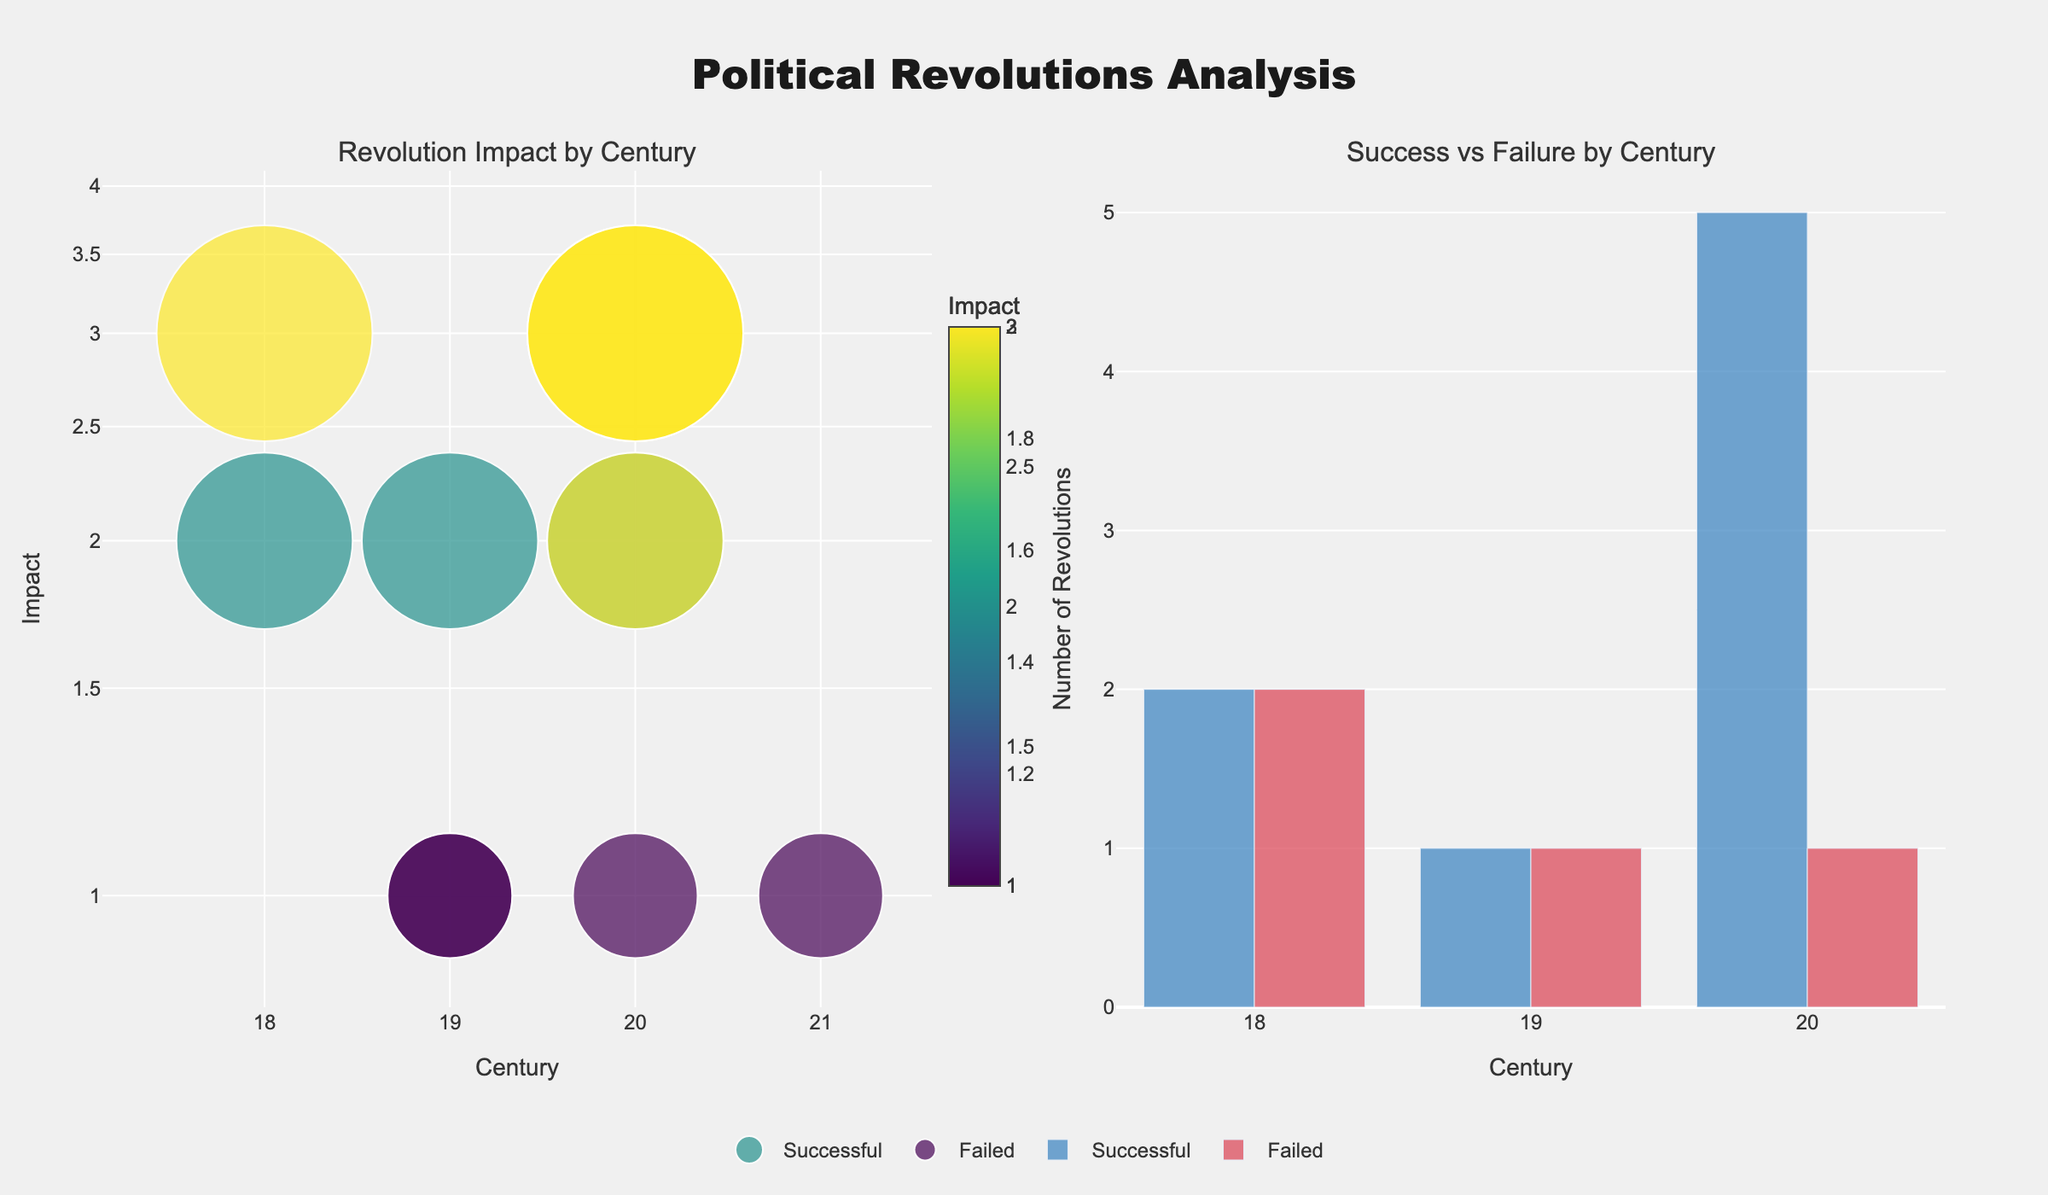Which century had the highest number of successful revolutions? To determine the century with the highest number of successful revolutions, examine the bar chart on the right. The height of the bars for each century indicates the count of successful revolutions. The 20th century has the tallest bar labeled 'Successful', indicating the highest count.
Answer: 20th century Which revolution in the 18th century had the highest impact? Look at the scatter plot on the left, where Revolution Impact is shown by the size and color of the markers. For the 18th century, the 'French Revolution' is marked with the largest and darkest color, representing 'Very High' impact.
Answer: French Revolution How many revolutions failed in the 19th century? On the bar chart on the right, locate the bar labeled 'Failed' for the 19th century. The bar's height indicates that there were two failed revolutions.
Answer: 2 What was the average impact of successful revolutions in the 20th century? Refer to the scatter plot on the left and identify the successful revolutions in the 20th century. The impacts are 'Very High' (3), 'Very High' (3), 'High' (2), 'Medium' (1), and 'Very High' (3). The average impact is (3+3+2+1+3)/5 = 2.4.
Answer: 2.4 Which century witnessed the highest combined number of revolutions? By adding up the counts of both successful and failed revolutions in each century from the bar chart on the right, the 20th century has the highest total with five successful and one failed revolution, totaling six.
Answer: 20th century Was the impact of the Meiji Restoration higher or lower compared to the Velvet Revolution? Consult the scatter plot on the left for the markers corresponding to the 'Meiji Restoration' and 'Velvet Revolution.' The Meiji Restoration shows an impact of 'High' (2), while the Velvet Revolution shows 'Medium' (1).
Answer: Higher In which century do all revolutions have an equal impact? From the scatter plot on the left, assess each century. In the 21st century, all revolutions have 'Medium' impact markers.
Answer: 21st century What is the total number of revolutions in the 20th century? Sum the successful and failed revolutions for the 20th century from the bar chart on the right. With five successful and one failed, the total is six.
Answer: 6 